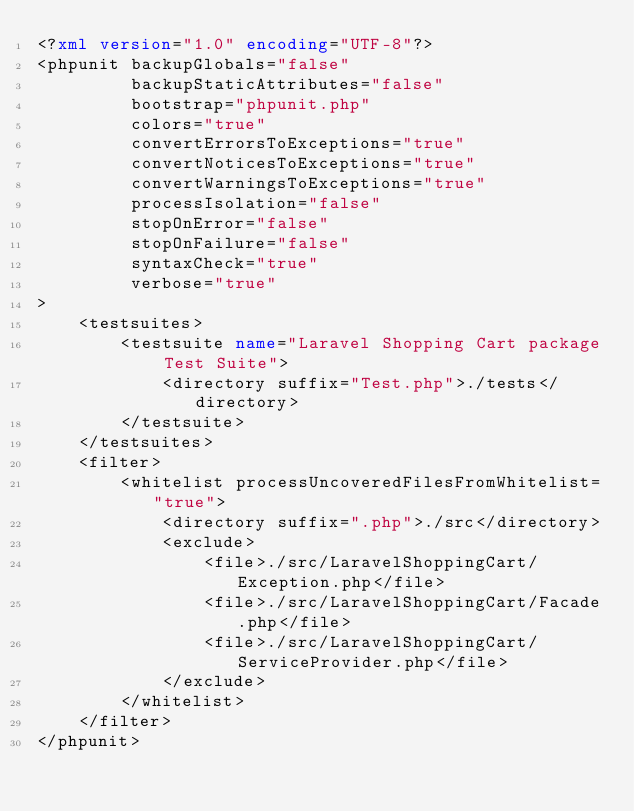<code> <loc_0><loc_0><loc_500><loc_500><_XML_><?xml version="1.0" encoding="UTF-8"?>
<phpunit backupGlobals="false"
         backupStaticAttributes="false"
         bootstrap="phpunit.php"
         colors="true"
         convertErrorsToExceptions="true"
         convertNoticesToExceptions="true"
         convertWarningsToExceptions="true"
         processIsolation="false"
         stopOnError="false"
         stopOnFailure="false"
         syntaxCheck="true"
         verbose="true"
>
    <testsuites>
        <testsuite name="Laravel Shopping Cart package Test Suite">
            <directory suffix="Test.php">./tests</directory>
        </testsuite>
    </testsuites>
    <filter>
        <whitelist processUncoveredFilesFromWhitelist="true">
            <directory suffix=".php">./src</directory>
            <exclude>
                <file>./src/LaravelShoppingCart/Exception.php</file>
                <file>./src/LaravelShoppingCart/Facade.php</file>
                <file>./src/LaravelShoppingCart/ServiceProvider.php</file>
            </exclude>
        </whitelist>
    </filter>
</phpunit></code> 